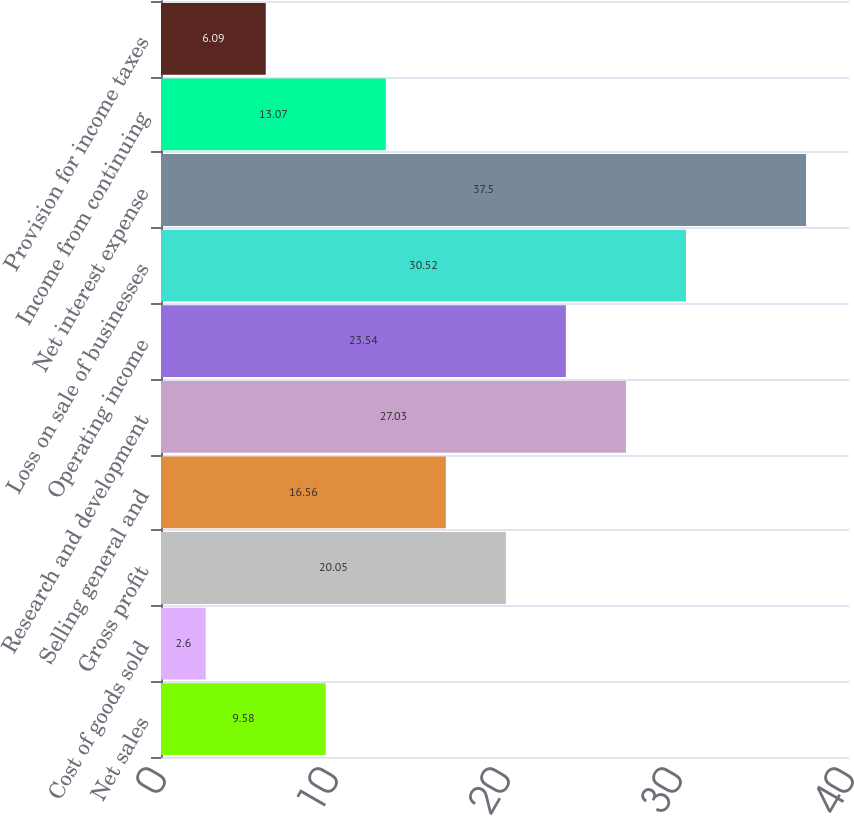Convert chart to OTSL. <chart><loc_0><loc_0><loc_500><loc_500><bar_chart><fcel>Net sales<fcel>Cost of goods sold<fcel>Gross profit<fcel>Selling general and<fcel>Research and development<fcel>Operating income<fcel>Loss on sale of businesses<fcel>Net interest expense<fcel>Income from continuing<fcel>Provision for income taxes<nl><fcel>9.58<fcel>2.6<fcel>20.05<fcel>16.56<fcel>27.03<fcel>23.54<fcel>30.52<fcel>37.5<fcel>13.07<fcel>6.09<nl></chart> 